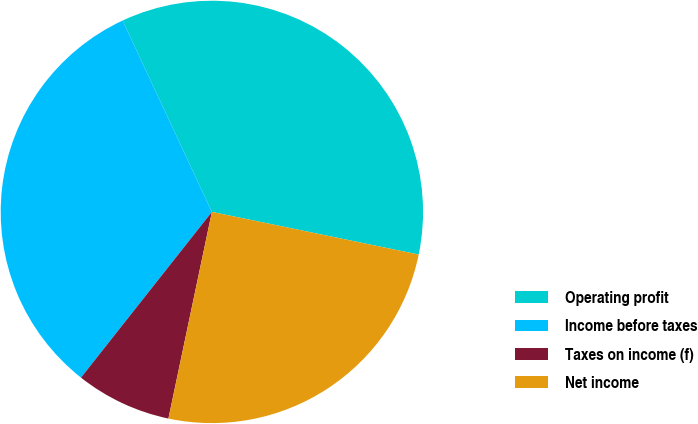Convert chart to OTSL. <chart><loc_0><loc_0><loc_500><loc_500><pie_chart><fcel>Operating profit<fcel>Income before taxes<fcel>Taxes on income (f)<fcel>Net income<nl><fcel>35.18%<fcel>32.41%<fcel>7.34%<fcel>25.06%<nl></chart> 